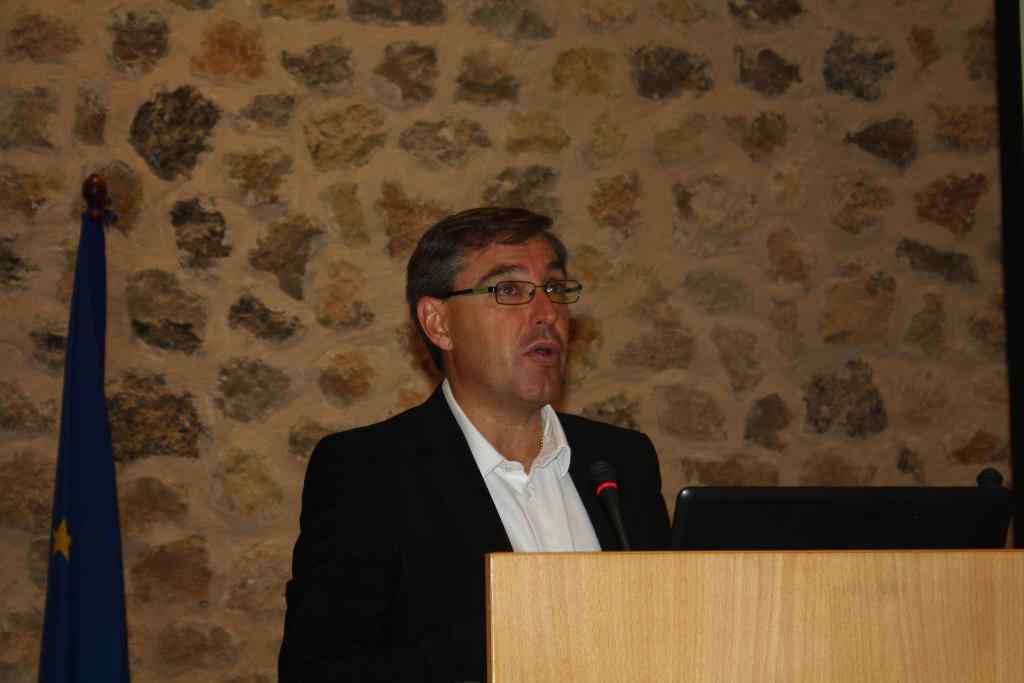What can be seen in the image? There is a person in the image. Can you describe the person's appearance? The person is wearing glasses. What objects are present in the image? There is a mic and a laptop in the image. Where are the mic and laptop located? The mic and laptop are on a podium. What can be seen in the background of the image? There is a flag and a wall in the background of the image. What type of thunder can be heard in the image? There is no thunder present in the image; it is a still image with no sound. 